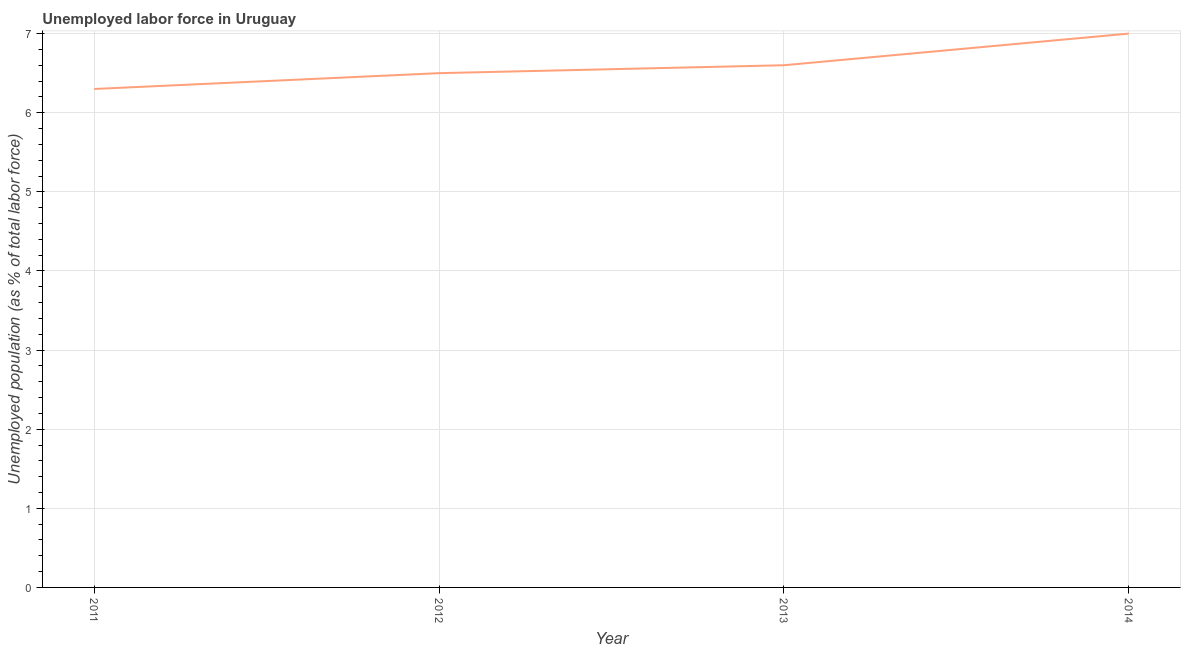Across all years, what is the minimum total unemployed population?
Offer a very short reply. 6.3. In which year was the total unemployed population maximum?
Give a very brief answer. 2014. What is the sum of the total unemployed population?
Make the answer very short. 26.4. What is the difference between the total unemployed population in 2011 and 2013?
Provide a succinct answer. -0.3. What is the average total unemployed population per year?
Ensure brevity in your answer.  6.6. What is the median total unemployed population?
Make the answer very short. 6.55. What is the ratio of the total unemployed population in 2013 to that in 2014?
Ensure brevity in your answer.  0.94. Is the total unemployed population in 2011 less than that in 2013?
Give a very brief answer. Yes. What is the difference between the highest and the second highest total unemployed population?
Your answer should be compact. 0.4. What is the difference between the highest and the lowest total unemployed population?
Your response must be concise. 0.7. Does the total unemployed population monotonically increase over the years?
Provide a short and direct response. Yes. How many years are there in the graph?
Your answer should be very brief. 4. Are the values on the major ticks of Y-axis written in scientific E-notation?
Your answer should be compact. No. Does the graph contain any zero values?
Provide a short and direct response. No. What is the title of the graph?
Your answer should be compact. Unemployed labor force in Uruguay. What is the label or title of the Y-axis?
Provide a succinct answer. Unemployed population (as % of total labor force). What is the Unemployed population (as % of total labor force) of 2011?
Make the answer very short. 6.3. What is the Unemployed population (as % of total labor force) in 2012?
Offer a terse response. 6.5. What is the Unemployed population (as % of total labor force) in 2013?
Provide a succinct answer. 6.6. What is the difference between the Unemployed population (as % of total labor force) in 2011 and 2014?
Offer a terse response. -0.7. What is the difference between the Unemployed population (as % of total labor force) in 2012 and 2013?
Provide a succinct answer. -0.1. What is the difference between the Unemployed population (as % of total labor force) in 2012 and 2014?
Provide a short and direct response. -0.5. What is the difference between the Unemployed population (as % of total labor force) in 2013 and 2014?
Provide a succinct answer. -0.4. What is the ratio of the Unemployed population (as % of total labor force) in 2011 to that in 2012?
Your answer should be very brief. 0.97. What is the ratio of the Unemployed population (as % of total labor force) in 2011 to that in 2013?
Ensure brevity in your answer.  0.95. What is the ratio of the Unemployed population (as % of total labor force) in 2012 to that in 2014?
Your answer should be very brief. 0.93. What is the ratio of the Unemployed population (as % of total labor force) in 2013 to that in 2014?
Make the answer very short. 0.94. 